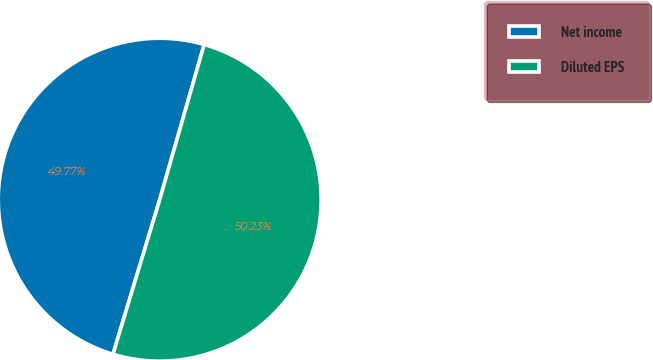<chart> <loc_0><loc_0><loc_500><loc_500><pie_chart><fcel>Net income<fcel>Diluted EPS<nl><fcel>49.77%<fcel>50.23%<nl></chart> 